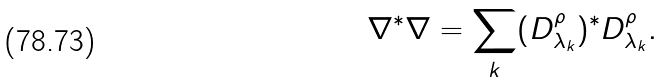Convert formula to latex. <formula><loc_0><loc_0><loc_500><loc_500>\nabla ^ { \ast } \nabla = \sum _ { k } ( D ^ { \rho } _ { \lambda _ { k } } ) ^ { \ast } D ^ { \rho } _ { \lambda _ { k } } .</formula> 